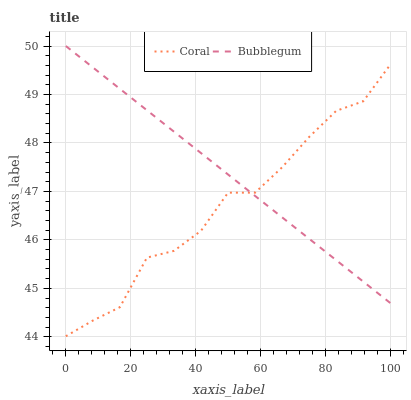Does Coral have the minimum area under the curve?
Answer yes or no. Yes. Does Bubblegum have the maximum area under the curve?
Answer yes or no. Yes. Does Bubblegum have the minimum area under the curve?
Answer yes or no. No. Is Bubblegum the smoothest?
Answer yes or no. Yes. Is Coral the roughest?
Answer yes or no. Yes. Is Bubblegum the roughest?
Answer yes or no. No. Does Bubblegum have the lowest value?
Answer yes or no. No. 